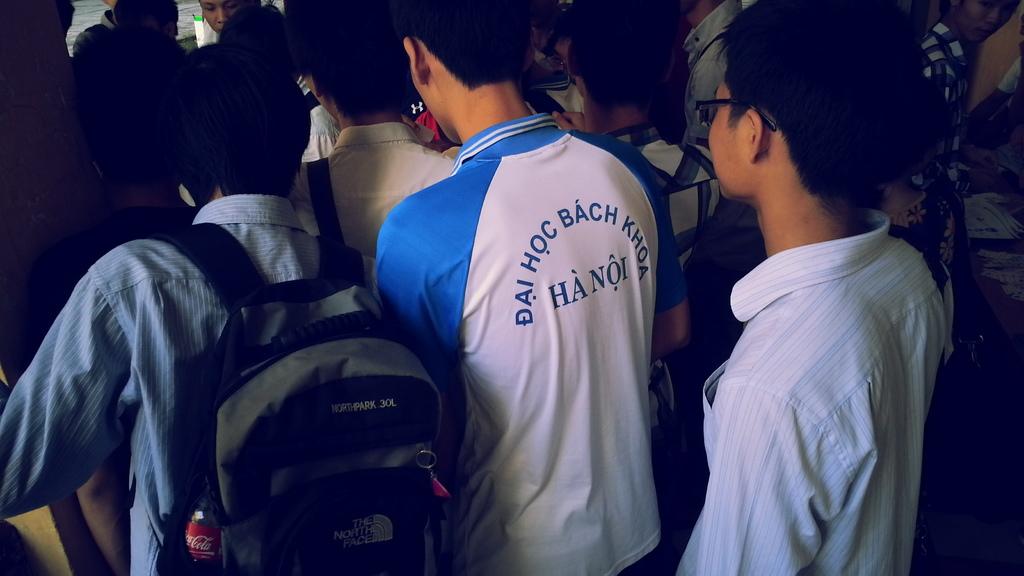What city is mentioned on the man's blue and white shirt?
Make the answer very short. Hanoi. What is the first word in the string of words curve across the back of the shirt?
Offer a terse response. Dai. 